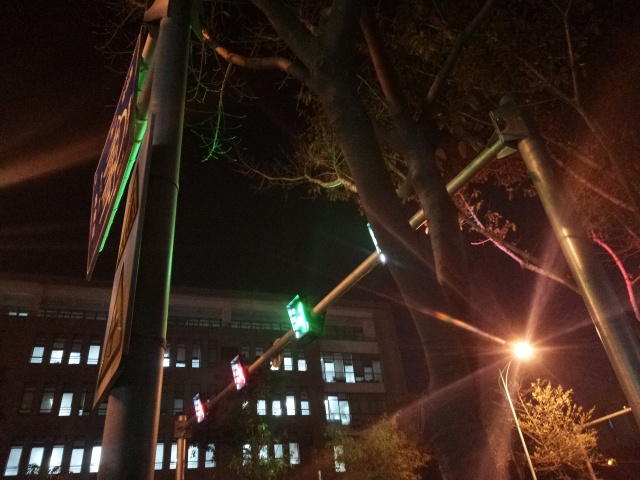Based on the lighting and surroundings, what kind of area does this photo depict? The photo depicts an urban area, likely a part of a city with commercial or office buildings. The presence of a traffic light suggests a road intersection nearby, and the lighting implies that the area is equipped for nighttime activity, though it appears to be devoid of pedestrians or significant traffic at the moment. 